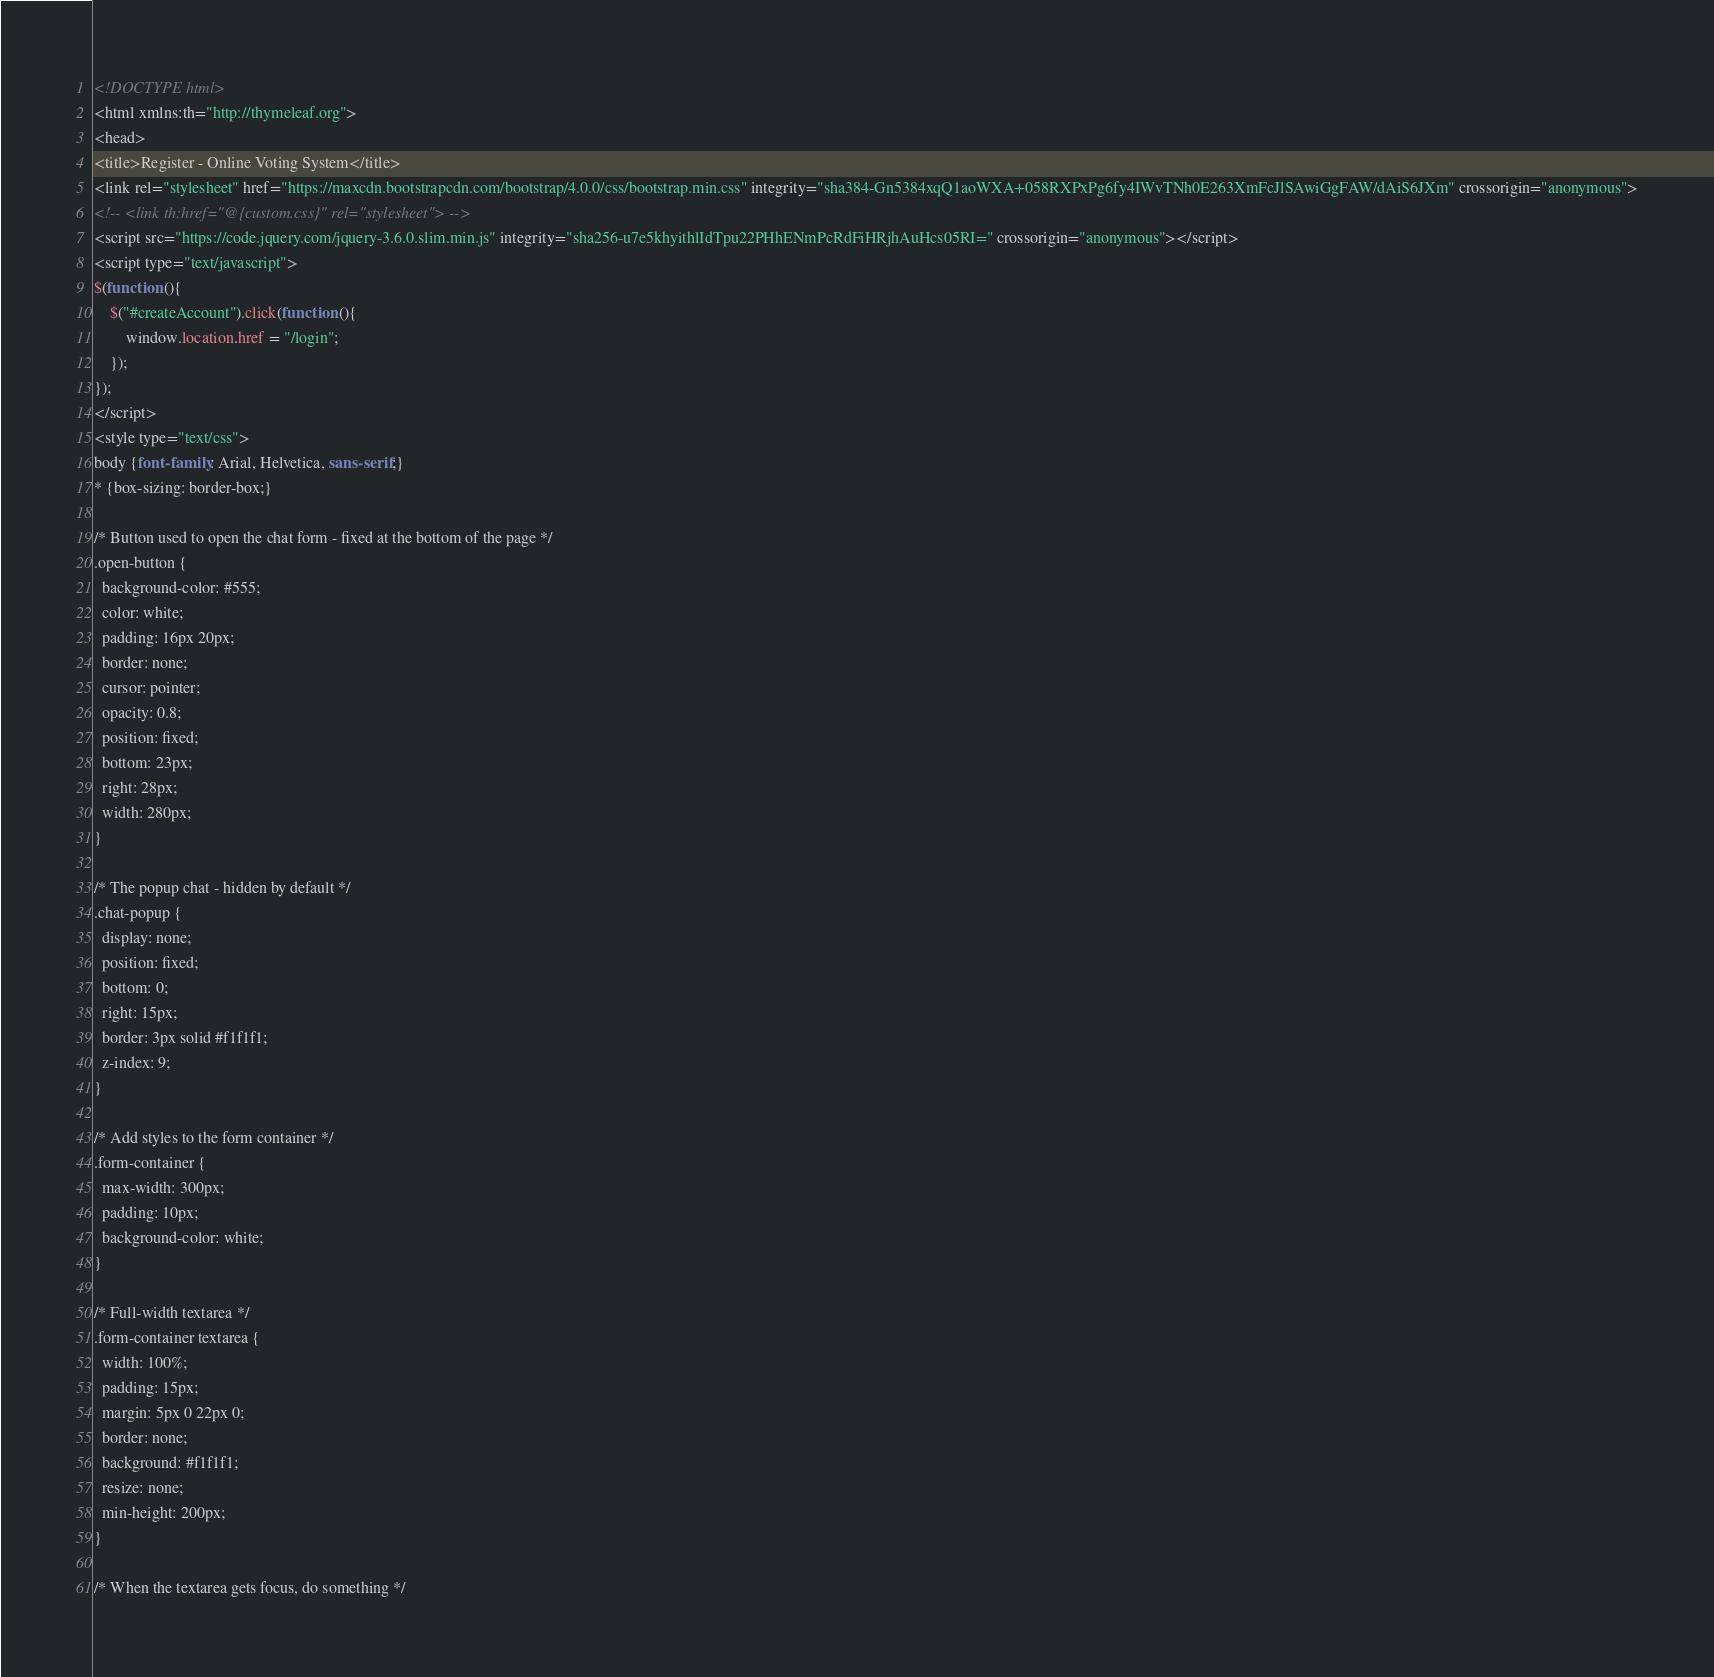Convert code to text. <code><loc_0><loc_0><loc_500><loc_500><_HTML_><!DOCTYPE html>
<html xmlns:th="http://thymeleaf.org">
<head>
<title>Register - Online Voting System</title>
<link rel="stylesheet" href="https://maxcdn.bootstrapcdn.com/bootstrap/4.0.0/css/bootstrap.min.css" integrity="sha384-Gn5384xqQ1aoWXA+058RXPxPg6fy4IWvTNh0E263XmFcJlSAwiGgFAW/dAiS6JXm" crossorigin="anonymous">
<!-- <link th:href="@{custom.css}" rel="stylesheet"> -->
<script src="https://code.jquery.com/jquery-3.6.0.slim.min.js" integrity="sha256-u7e5khyithlIdTpu22PHhENmPcRdFiHRjhAuHcs05RI=" crossorigin="anonymous"></script>
<script type="text/javascript">
$(function (){
	$("#createAccount").click(function (){
		window.location.href = "/login";
	});
});
</script>
<style type="text/css">
body {font-family: Arial, Helvetica, sans-serif;}
* {box-sizing: border-box;}

/* Button used to open the chat form - fixed at the bottom of the page */
.open-button {
  background-color: #555;
  color: white;
  padding: 16px 20px;
  border: none;
  cursor: pointer;
  opacity: 0.8;
  position: fixed;
  bottom: 23px;
  right: 28px;
  width: 280px;
}

/* The popup chat - hidden by default */
.chat-popup {
  display: none;
  position: fixed;
  bottom: 0;
  right: 15px;
  border: 3px solid #f1f1f1;
  z-index: 9;
}

/* Add styles to the form container */
.form-container {
  max-width: 300px;
  padding: 10px;
  background-color: white;
}

/* Full-width textarea */
.form-container textarea {
  width: 100%;
  padding: 15px;
  margin: 5px 0 22px 0;
  border: none;
  background: #f1f1f1;
  resize: none;
  min-height: 200px;
}

/* When the textarea gets focus, do something */</code> 